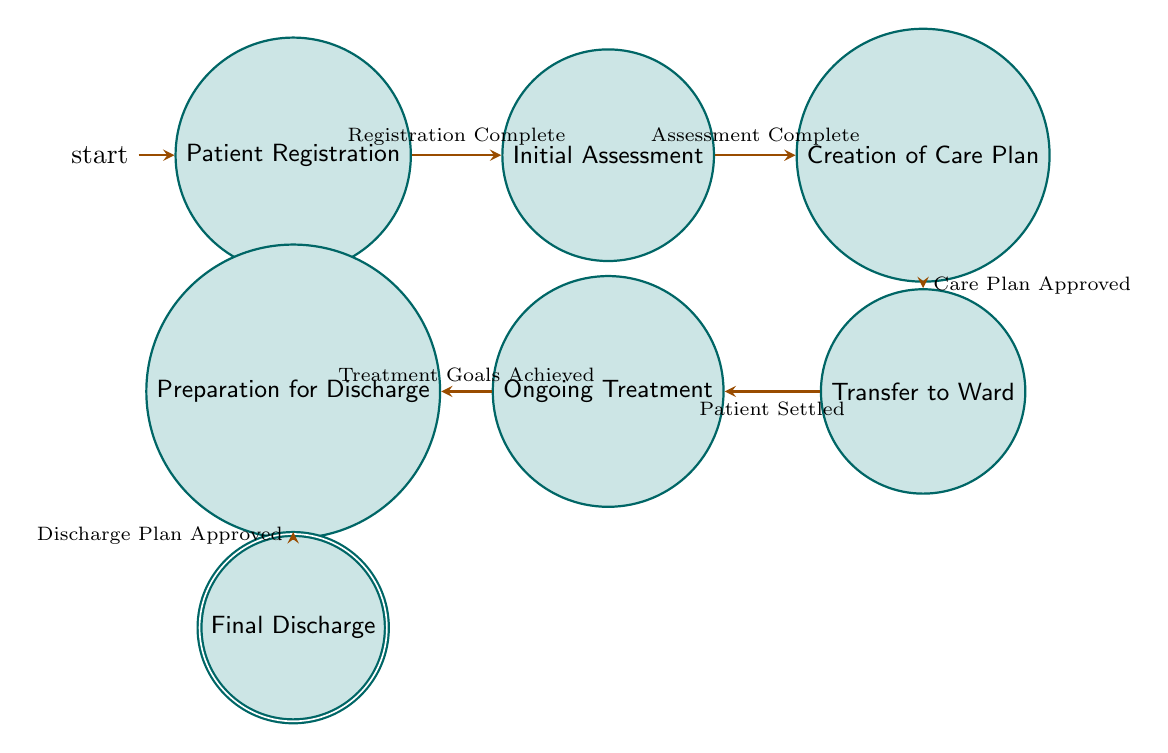What is the starting state in the diagram? The starting state is represented by the initial marker, which is "Patient Registration." This state is designated to signify where the process begins.
Answer: Patient Registration How many states are depicted in the diagram? To find the total number of states, count each individual state listed in the diagram: "Patient Registration," "Initial Assessment," "Creation of Care Plan," "Transfer to Ward," "Ongoing Treatment," "Preparation for Discharge," and "Final Discharge," which totals to seven states.
Answer: Seven What is the transition condition from "Initial Assessment" to "Creation of Care Plan"? Look at the edge that connects "Initial Assessment" to "Creation of Care Plan," which states the condition required to move from one state to the next. This condition is "Assessment Complete."
Answer: Assessment Complete Which state do you reach after "Preparation for Discharge"? Check the direct transition from "Preparation for Discharge." According to the diagram, this state leads directly to "Final Discharge," indicating that this is the next point in the process.
Answer: Final Discharge What is the last state in the process? The last state, which signifies the completion of the process illustrated in the diagram, can be identified by looking for the accepting state. This state is labeled as "Final Discharge."
Answer: Final Discharge How many transitions are there in total? To determine the total number of transitions, count the edges connecting the states in the diagram. There are six edges that represent direct transitions from one state to the next based on the conditions provided.
Answer: Six What condition must be met for a patient to transition from "Transfer to Ward" to "Ongoing Treatment"? Review the edge connecting "Transfer to Ward" and "Ongoing Treatment." The condition that allows this transition to occur is "Patient Settled."
Answer: Patient Settled Is "Care Plan Approved" necessary for transitioning from "Creation of Care Plan" to "Transfer to Ward"? Yes, "Care Plan Approved" is required as the enabling condition for the transition from "Creation of Care Plan" to "Transfer to Ward," indicating that the care plan must be validated before proceeding.
Answer: Yes 